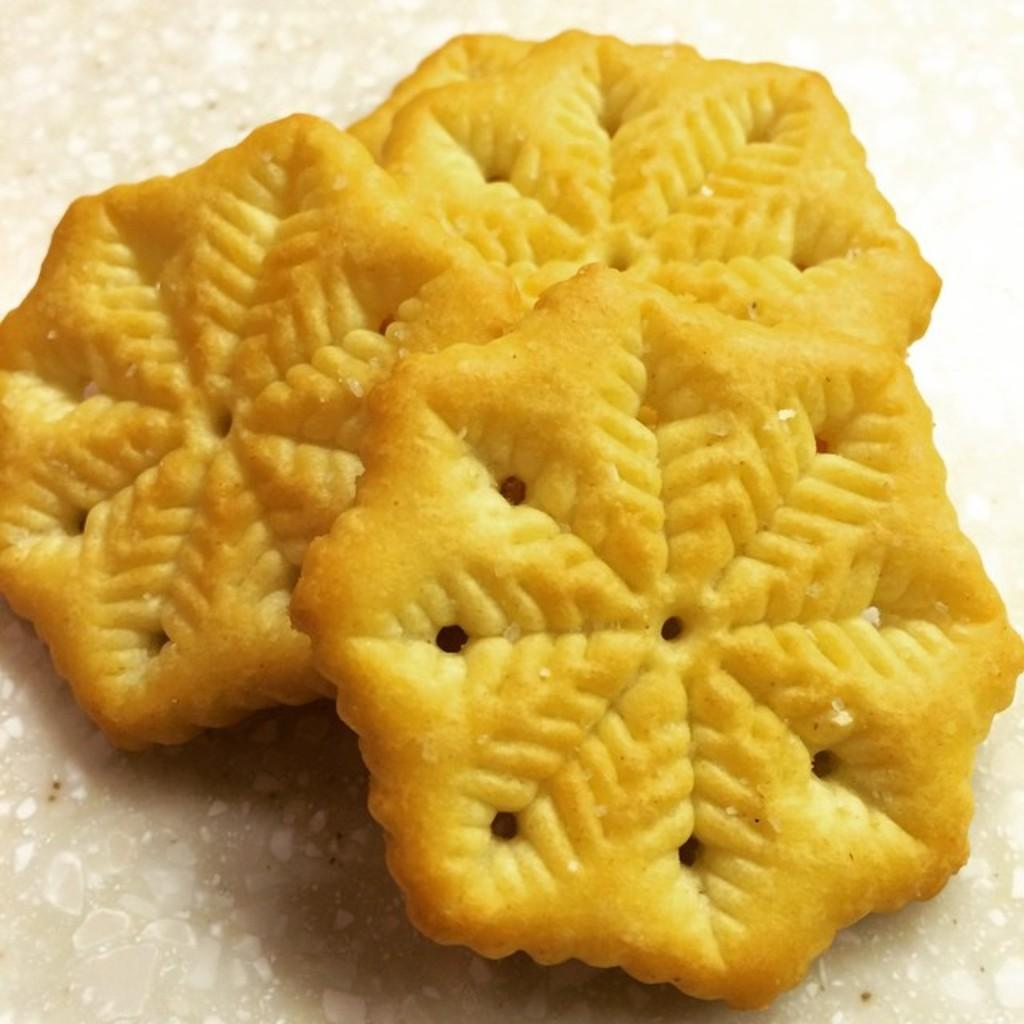What type of food can be seen in the image? There are biscuits in the image. How many times does the biscuit roll in the image? There is no indication in the image that the biscuit is rolling, so it cannot be determined from the picture. 